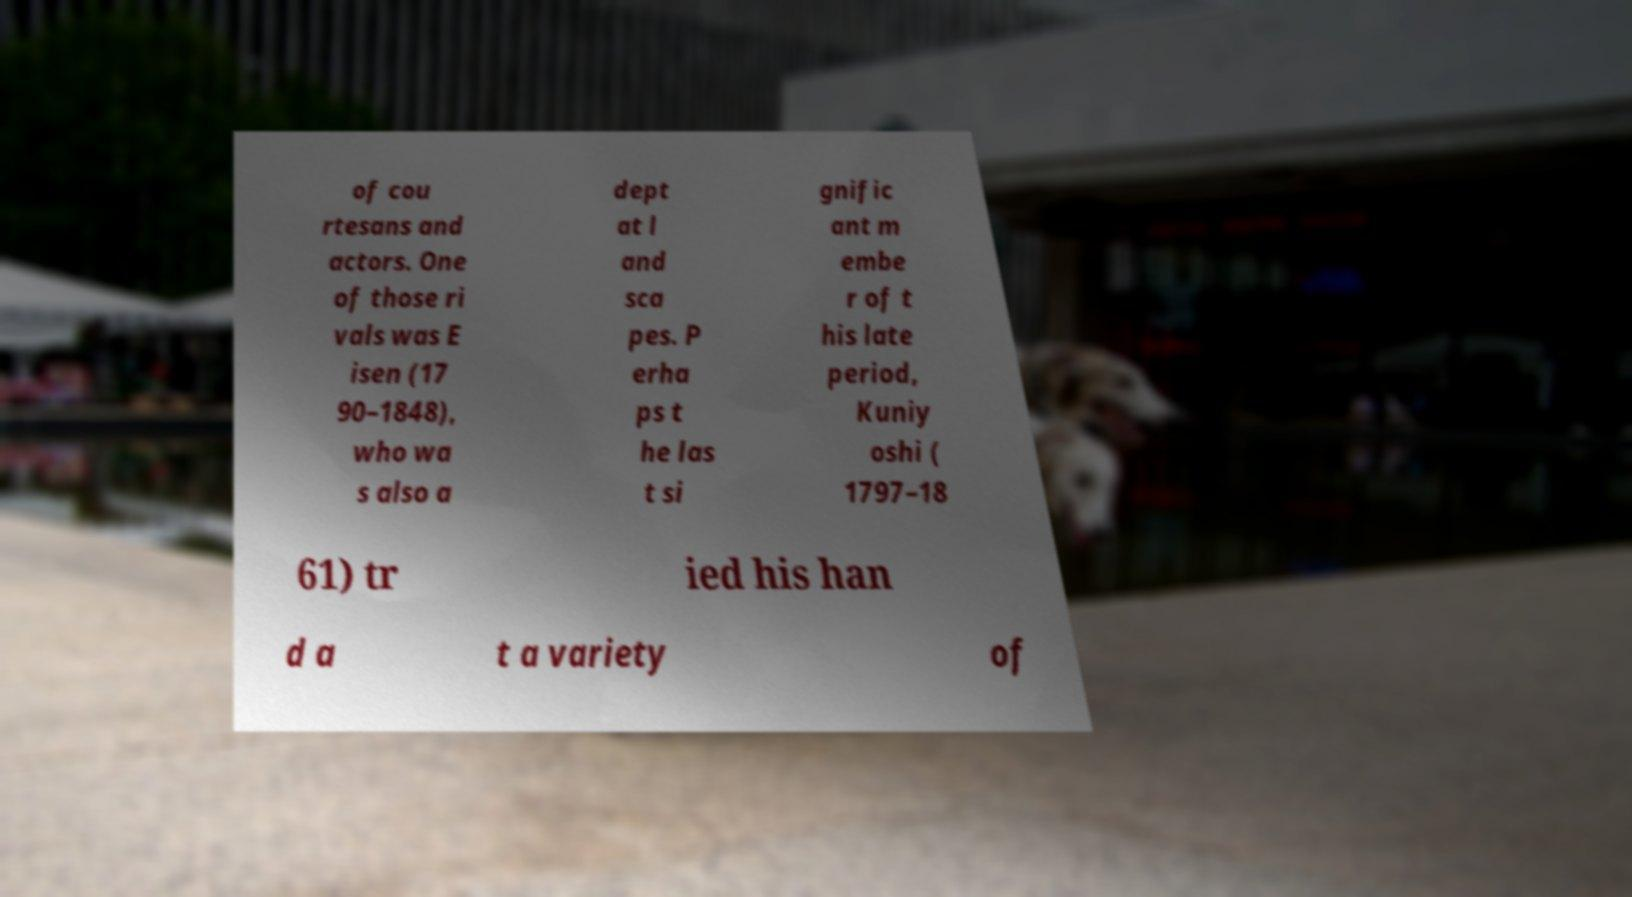I need the written content from this picture converted into text. Can you do that? of cou rtesans and actors. One of those ri vals was E isen (17 90–1848), who wa s also a dept at l and sca pes. P erha ps t he las t si gnific ant m embe r of t his late period, Kuniy oshi ( 1797–18 61) tr ied his han d a t a variety of 